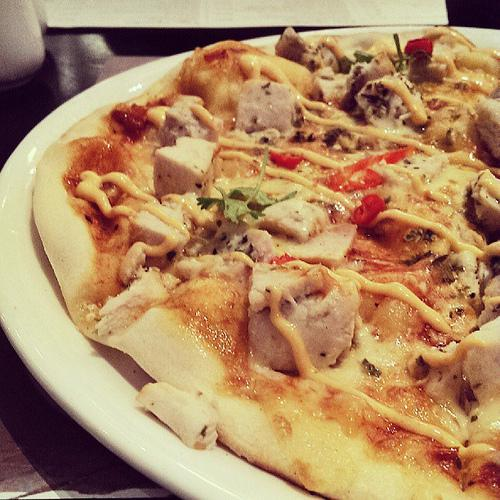Question: why is the cheese melted?
Choices:
A. It was baked.
B. It got warm.
C. It was cooked.
D. It was fried.
Answer with the letter. Answer: A Question: what color is the crust?
Choices:
A. Brown.
B. Black.
C. Golden.
D. Yellow.
Answer with the letter. Answer: C Question: where is the pizza?
Choices:
A. In the oven.
B. On a plate.
C. On the counter.
D. On the table.
Answer with the letter. Answer: B Question: when was this picture taken?
Choices:
A. At a meal time.
B. Dinner time.
C. Lunch time.
D. During Breakfast.
Answer with the letter. Answer: A 